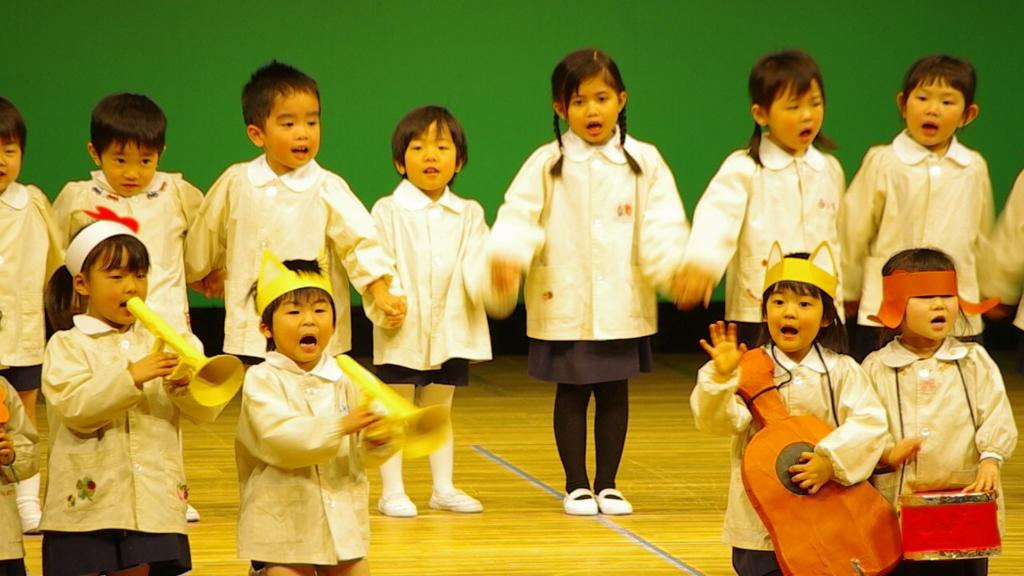What can be seen in the image? There are kids in the image. Where are the kids located? The kids are standing on a stage. What are the kids doing on the stage? The kids are singing. What can be seen in the background of the image? There is a green curtain in the background of the image. What type of kettle is visible on the stage with the kids? There is no kettle present in the image; it only features kids standing on a stage and singing. 